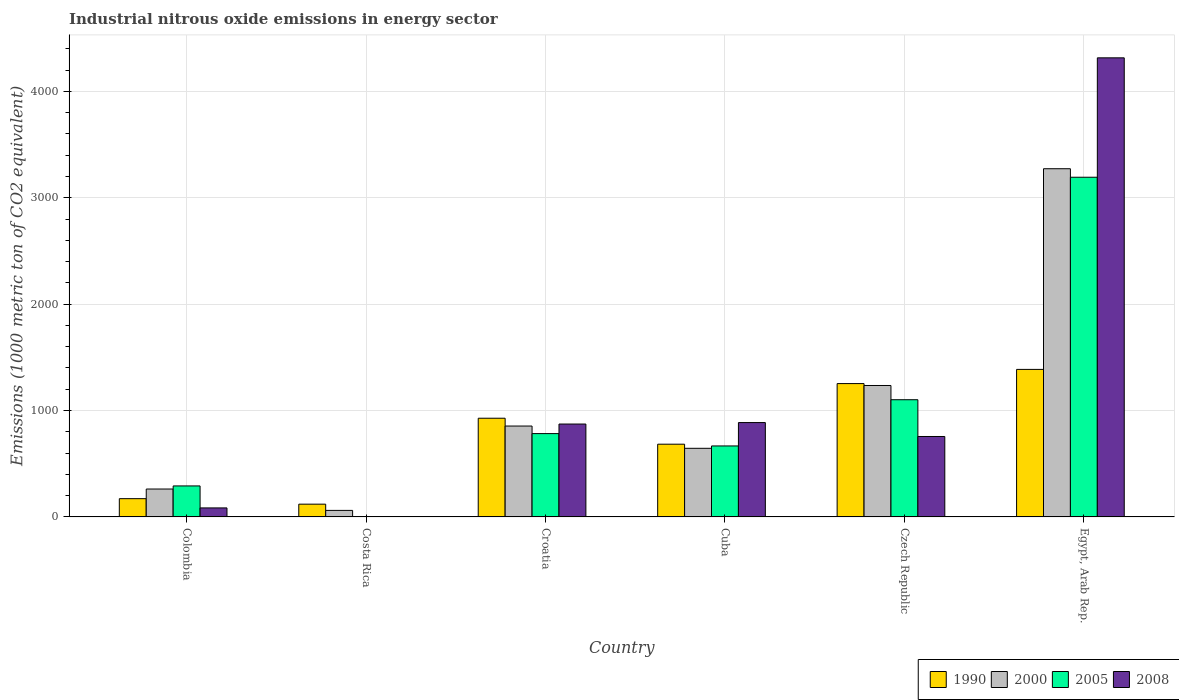How many different coloured bars are there?
Offer a very short reply. 4. What is the label of the 5th group of bars from the left?
Provide a succinct answer. Czech Republic. In how many cases, is the number of bars for a given country not equal to the number of legend labels?
Give a very brief answer. 0. What is the amount of industrial nitrous oxide emitted in 1990 in Czech Republic?
Keep it short and to the point. 1253.3. Across all countries, what is the maximum amount of industrial nitrous oxide emitted in 2008?
Your response must be concise. 4315. Across all countries, what is the minimum amount of industrial nitrous oxide emitted in 2005?
Your answer should be very brief. 3.1. In which country was the amount of industrial nitrous oxide emitted in 2008 maximum?
Ensure brevity in your answer.  Egypt, Arab Rep. What is the total amount of industrial nitrous oxide emitted in 2008 in the graph?
Make the answer very short. 6918.7. What is the difference between the amount of industrial nitrous oxide emitted in 2005 in Colombia and that in Czech Republic?
Ensure brevity in your answer.  -810.2. What is the difference between the amount of industrial nitrous oxide emitted in 2005 in Costa Rica and the amount of industrial nitrous oxide emitted in 1990 in Colombia?
Provide a succinct answer. -168.5. What is the average amount of industrial nitrous oxide emitted in 1990 per country?
Your answer should be very brief. 757.13. What is the difference between the amount of industrial nitrous oxide emitted of/in 2008 and amount of industrial nitrous oxide emitted of/in 2005 in Croatia?
Make the answer very short. 89.8. In how many countries, is the amount of industrial nitrous oxide emitted in 2000 greater than 1800 1000 metric ton?
Offer a very short reply. 1. What is the ratio of the amount of industrial nitrous oxide emitted in 1990 in Colombia to that in Czech Republic?
Offer a terse response. 0.14. What is the difference between the highest and the second highest amount of industrial nitrous oxide emitted in 2000?
Make the answer very short. 2037.3. What is the difference between the highest and the lowest amount of industrial nitrous oxide emitted in 2005?
Offer a very short reply. 3189.5. In how many countries, is the amount of industrial nitrous oxide emitted in 2008 greater than the average amount of industrial nitrous oxide emitted in 2008 taken over all countries?
Give a very brief answer. 1. Is the sum of the amount of industrial nitrous oxide emitted in 2000 in Colombia and Cuba greater than the maximum amount of industrial nitrous oxide emitted in 1990 across all countries?
Give a very brief answer. No. Are all the bars in the graph horizontal?
Ensure brevity in your answer.  No. How many countries are there in the graph?
Keep it short and to the point. 6. What is the difference between two consecutive major ticks on the Y-axis?
Provide a succinct answer. 1000. How many legend labels are there?
Give a very brief answer. 4. What is the title of the graph?
Give a very brief answer. Industrial nitrous oxide emissions in energy sector. Does "1969" appear as one of the legend labels in the graph?
Provide a short and direct response. No. What is the label or title of the Y-axis?
Offer a very short reply. Emissions (1000 metric ton of CO2 equivalent). What is the Emissions (1000 metric ton of CO2 equivalent) in 1990 in Colombia?
Your response must be concise. 171.6. What is the Emissions (1000 metric ton of CO2 equivalent) of 2000 in Colombia?
Your response must be concise. 262.3. What is the Emissions (1000 metric ton of CO2 equivalent) in 2005 in Colombia?
Make the answer very short. 291.3. What is the Emissions (1000 metric ton of CO2 equivalent) of 2008 in Colombia?
Offer a terse response. 84.7. What is the Emissions (1000 metric ton of CO2 equivalent) of 1990 in Costa Rica?
Your response must be concise. 120. What is the Emissions (1000 metric ton of CO2 equivalent) in 2000 in Costa Rica?
Keep it short and to the point. 61.4. What is the Emissions (1000 metric ton of CO2 equivalent) of 1990 in Croatia?
Your response must be concise. 927.7. What is the Emissions (1000 metric ton of CO2 equivalent) of 2000 in Croatia?
Your response must be concise. 854.3. What is the Emissions (1000 metric ton of CO2 equivalent) of 2005 in Croatia?
Give a very brief answer. 783.2. What is the Emissions (1000 metric ton of CO2 equivalent) of 2008 in Croatia?
Give a very brief answer. 873. What is the Emissions (1000 metric ton of CO2 equivalent) in 1990 in Cuba?
Provide a short and direct response. 683.6. What is the Emissions (1000 metric ton of CO2 equivalent) in 2000 in Cuba?
Your response must be concise. 645. What is the Emissions (1000 metric ton of CO2 equivalent) of 2005 in Cuba?
Provide a succinct answer. 667.1. What is the Emissions (1000 metric ton of CO2 equivalent) of 2008 in Cuba?
Your answer should be very brief. 886.9. What is the Emissions (1000 metric ton of CO2 equivalent) of 1990 in Czech Republic?
Provide a succinct answer. 1253.3. What is the Emissions (1000 metric ton of CO2 equivalent) of 2000 in Czech Republic?
Ensure brevity in your answer.  1235.4. What is the Emissions (1000 metric ton of CO2 equivalent) in 2005 in Czech Republic?
Offer a very short reply. 1101.5. What is the Emissions (1000 metric ton of CO2 equivalent) of 2008 in Czech Republic?
Offer a very short reply. 756. What is the Emissions (1000 metric ton of CO2 equivalent) in 1990 in Egypt, Arab Rep.?
Provide a succinct answer. 1386.6. What is the Emissions (1000 metric ton of CO2 equivalent) of 2000 in Egypt, Arab Rep.?
Keep it short and to the point. 3272.7. What is the Emissions (1000 metric ton of CO2 equivalent) of 2005 in Egypt, Arab Rep.?
Provide a succinct answer. 3192.6. What is the Emissions (1000 metric ton of CO2 equivalent) of 2008 in Egypt, Arab Rep.?
Offer a terse response. 4315. Across all countries, what is the maximum Emissions (1000 metric ton of CO2 equivalent) of 1990?
Provide a succinct answer. 1386.6. Across all countries, what is the maximum Emissions (1000 metric ton of CO2 equivalent) in 2000?
Offer a very short reply. 3272.7. Across all countries, what is the maximum Emissions (1000 metric ton of CO2 equivalent) of 2005?
Offer a terse response. 3192.6. Across all countries, what is the maximum Emissions (1000 metric ton of CO2 equivalent) in 2008?
Offer a very short reply. 4315. Across all countries, what is the minimum Emissions (1000 metric ton of CO2 equivalent) in 1990?
Your answer should be very brief. 120. Across all countries, what is the minimum Emissions (1000 metric ton of CO2 equivalent) of 2000?
Make the answer very short. 61.4. What is the total Emissions (1000 metric ton of CO2 equivalent) of 1990 in the graph?
Offer a terse response. 4542.8. What is the total Emissions (1000 metric ton of CO2 equivalent) in 2000 in the graph?
Your answer should be very brief. 6331.1. What is the total Emissions (1000 metric ton of CO2 equivalent) in 2005 in the graph?
Give a very brief answer. 6038.8. What is the total Emissions (1000 metric ton of CO2 equivalent) of 2008 in the graph?
Your response must be concise. 6918.7. What is the difference between the Emissions (1000 metric ton of CO2 equivalent) of 1990 in Colombia and that in Costa Rica?
Your answer should be very brief. 51.6. What is the difference between the Emissions (1000 metric ton of CO2 equivalent) of 2000 in Colombia and that in Costa Rica?
Offer a terse response. 200.9. What is the difference between the Emissions (1000 metric ton of CO2 equivalent) of 2005 in Colombia and that in Costa Rica?
Provide a short and direct response. 288.2. What is the difference between the Emissions (1000 metric ton of CO2 equivalent) of 2008 in Colombia and that in Costa Rica?
Your response must be concise. 81.6. What is the difference between the Emissions (1000 metric ton of CO2 equivalent) of 1990 in Colombia and that in Croatia?
Provide a succinct answer. -756.1. What is the difference between the Emissions (1000 metric ton of CO2 equivalent) of 2000 in Colombia and that in Croatia?
Offer a terse response. -592. What is the difference between the Emissions (1000 metric ton of CO2 equivalent) of 2005 in Colombia and that in Croatia?
Ensure brevity in your answer.  -491.9. What is the difference between the Emissions (1000 metric ton of CO2 equivalent) in 2008 in Colombia and that in Croatia?
Offer a very short reply. -788.3. What is the difference between the Emissions (1000 metric ton of CO2 equivalent) in 1990 in Colombia and that in Cuba?
Your answer should be very brief. -512. What is the difference between the Emissions (1000 metric ton of CO2 equivalent) of 2000 in Colombia and that in Cuba?
Ensure brevity in your answer.  -382.7. What is the difference between the Emissions (1000 metric ton of CO2 equivalent) in 2005 in Colombia and that in Cuba?
Keep it short and to the point. -375.8. What is the difference between the Emissions (1000 metric ton of CO2 equivalent) in 2008 in Colombia and that in Cuba?
Make the answer very short. -802.2. What is the difference between the Emissions (1000 metric ton of CO2 equivalent) in 1990 in Colombia and that in Czech Republic?
Ensure brevity in your answer.  -1081.7. What is the difference between the Emissions (1000 metric ton of CO2 equivalent) in 2000 in Colombia and that in Czech Republic?
Make the answer very short. -973.1. What is the difference between the Emissions (1000 metric ton of CO2 equivalent) of 2005 in Colombia and that in Czech Republic?
Ensure brevity in your answer.  -810.2. What is the difference between the Emissions (1000 metric ton of CO2 equivalent) in 2008 in Colombia and that in Czech Republic?
Provide a succinct answer. -671.3. What is the difference between the Emissions (1000 metric ton of CO2 equivalent) in 1990 in Colombia and that in Egypt, Arab Rep.?
Ensure brevity in your answer.  -1215. What is the difference between the Emissions (1000 metric ton of CO2 equivalent) of 2000 in Colombia and that in Egypt, Arab Rep.?
Offer a very short reply. -3010.4. What is the difference between the Emissions (1000 metric ton of CO2 equivalent) of 2005 in Colombia and that in Egypt, Arab Rep.?
Offer a terse response. -2901.3. What is the difference between the Emissions (1000 metric ton of CO2 equivalent) in 2008 in Colombia and that in Egypt, Arab Rep.?
Your answer should be compact. -4230.3. What is the difference between the Emissions (1000 metric ton of CO2 equivalent) in 1990 in Costa Rica and that in Croatia?
Your answer should be very brief. -807.7. What is the difference between the Emissions (1000 metric ton of CO2 equivalent) in 2000 in Costa Rica and that in Croatia?
Ensure brevity in your answer.  -792.9. What is the difference between the Emissions (1000 metric ton of CO2 equivalent) of 2005 in Costa Rica and that in Croatia?
Provide a succinct answer. -780.1. What is the difference between the Emissions (1000 metric ton of CO2 equivalent) in 2008 in Costa Rica and that in Croatia?
Your response must be concise. -869.9. What is the difference between the Emissions (1000 metric ton of CO2 equivalent) of 1990 in Costa Rica and that in Cuba?
Offer a terse response. -563.6. What is the difference between the Emissions (1000 metric ton of CO2 equivalent) of 2000 in Costa Rica and that in Cuba?
Keep it short and to the point. -583.6. What is the difference between the Emissions (1000 metric ton of CO2 equivalent) of 2005 in Costa Rica and that in Cuba?
Your answer should be compact. -664. What is the difference between the Emissions (1000 metric ton of CO2 equivalent) in 2008 in Costa Rica and that in Cuba?
Provide a short and direct response. -883.8. What is the difference between the Emissions (1000 metric ton of CO2 equivalent) of 1990 in Costa Rica and that in Czech Republic?
Your answer should be very brief. -1133.3. What is the difference between the Emissions (1000 metric ton of CO2 equivalent) of 2000 in Costa Rica and that in Czech Republic?
Offer a terse response. -1174. What is the difference between the Emissions (1000 metric ton of CO2 equivalent) of 2005 in Costa Rica and that in Czech Republic?
Your answer should be compact. -1098.4. What is the difference between the Emissions (1000 metric ton of CO2 equivalent) in 2008 in Costa Rica and that in Czech Republic?
Give a very brief answer. -752.9. What is the difference between the Emissions (1000 metric ton of CO2 equivalent) of 1990 in Costa Rica and that in Egypt, Arab Rep.?
Offer a terse response. -1266.6. What is the difference between the Emissions (1000 metric ton of CO2 equivalent) of 2000 in Costa Rica and that in Egypt, Arab Rep.?
Keep it short and to the point. -3211.3. What is the difference between the Emissions (1000 metric ton of CO2 equivalent) of 2005 in Costa Rica and that in Egypt, Arab Rep.?
Provide a short and direct response. -3189.5. What is the difference between the Emissions (1000 metric ton of CO2 equivalent) of 2008 in Costa Rica and that in Egypt, Arab Rep.?
Offer a very short reply. -4311.9. What is the difference between the Emissions (1000 metric ton of CO2 equivalent) of 1990 in Croatia and that in Cuba?
Give a very brief answer. 244.1. What is the difference between the Emissions (1000 metric ton of CO2 equivalent) in 2000 in Croatia and that in Cuba?
Your response must be concise. 209.3. What is the difference between the Emissions (1000 metric ton of CO2 equivalent) in 2005 in Croatia and that in Cuba?
Provide a succinct answer. 116.1. What is the difference between the Emissions (1000 metric ton of CO2 equivalent) of 1990 in Croatia and that in Czech Republic?
Your answer should be very brief. -325.6. What is the difference between the Emissions (1000 metric ton of CO2 equivalent) in 2000 in Croatia and that in Czech Republic?
Ensure brevity in your answer.  -381.1. What is the difference between the Emissions (1000 metric ton of CO2 equivalent) in 2005 in Croatia and that in Czech Republic?
Keep it short and to the point. -318.3. What is the difference between the Emissions (1000 metric ton of CO2 equivalent) in 2008 in Croatia and that in Czech Republic?
Provide a short and direct response. 117. What is the difference between the Emissions (1000 metric ton of CO2 equivalent) in 1990 in Croatia and that in Egypt, Arab Rep.?
Your response must be concise. -458.9. What is the difference between the Emissions (1000 metric ton of CO2 equivalent) of 2000 in Croatia and that in Egypt, Arab Rep.?
Offer a very short reply. -2418.4. What is the difference between the Emissions (1000 metric ton of CO2 equivalent) of 2005 in Croatia and that in Egypt, Arab Rep.?
Your response must be concise. -2409.4. What is the difference between the Emissions (1000 metric ton of CO2 equivalent) of 2008 in Croatia and that in Egypt, Arab Rep.?
Your answer should be compact. -3442. What is the difference between the Emissions (1000 metric ton of CO2 equivalent) of 1990 in Cuba and that in Czech Republic?
Your answer should be compact. -569.7. What is the difference between the Emissions (1000 metric ton of CO2 equivalent) in 2000 in Cuba and that in Czech Republic?
Offer a very short reply. -590.4. What is the difference between the Emissions (1000 metric ton of CO2 equivalent) in 2005 in Cuba and that in Czech Republic?
Your answer should be very brief. -434.4. What is the difference between the Emissions (1000 metric ton of CO2 equivalent) of 2008 in Cuba and that in Czech Republic?
Give a very brief answer. 130.9. What is the difference between the Emissions (1000 metric ton of CO2 equivalent) of 1990 in Cuba and that in Egypt, Arab Rep.?
Your response must be concise. -703. What is the difference between the Emissions (1000 metric ton of CO2 equivalent) of 2000 in Cuba and that in Egypt, Arab Rep.?
Keep it short and to the point. -2627.7. What is the difference between the Emissions (1000 metric ton of CO2 equivalent) in 2005 in Cuba and that in Egypt, Arab Rep.?
Keep it short and to the point. -2525.5. What is the difference between the Emissions (1000 metric ton of CO2 equivalent) of 2008 in Cuba and that in Egypt, Arab Rep.?
Provide a short and direct response. -3428.1. What is the difference between the Emissions (1000 metric ton of CO2 equivalent) in 1990 in Czech Republic and that in Egypt, Arab Rep.?
Offer a very short reply. -133.3. What is the difference between the Emissions (1000 metric ton of CO2 equivalent) in 2000 in Czech Republic and that in Egypt, Arab Rep.?
Provide a succinct answer. -2037.3. What is the difference between the Emissions (1000 metric ton of CO2 equivalent) of 2005 in Czech Republic and that in Egypt, Arab Rep.?
Make the answer very short. -2091.1. What is the difference between the Emissions (1000 metric ton of CO2 equivalent) of 2008 in Czech Republic and that in Egypt, Arab Rep.?
Your response must be concise. -3559. What is the difference between the Emissions (1000 metric ton of CO2 equivalent) in 1990 in Colombia and the Emissions (1000 metric ton of CO2 equivalent) in 2000 in Costa Rica?
Provide a succinct answer. 110.2. What is the difference between the Emissions (1000 metric ton of CO2 equivalent) in 1990 in Colombia and the Emissions (1000 metric ton of CO2 equivalent) in 2005 in Costa Rica?
Your response must be concise. 168.5. What is the difference between the Emissions (1000 metric ton of CO2 equivalent) of 1990 in Colombia and the Emissions (1000 metric ton of CO2 equivalent) of 2008 in Costa Rica?
Provide a short and direct response. 168.5. What is the difference between the Emissions (1000 metric ton of CO2 equivalent) of 2000 in Colombia and the Emissions (1000 metric ton of CO2 equivalent) of 2005 in Costa Rica?
Your response must be concise. 259.2. What is the difference between the Emissions (1000 metric ton of CO2 equivalent) of 2000 in Colombia and the Emissions (1000 metric ton of CO2 equivalent) of 2008 in Costa Rica?
Your answer should be very brief. 259.2. What is the difference between the Emissions (1000 metric ton of CO2 equivalent) of 2005 in Colombia and the Emissions (1000 metric ton of CO2 equivalent) of 2008 in Costa Rica?
Your response must be concise. 288.2. What is the difference between the Emissions (1000 metric ton of CO2 equivalent) in 1990 in Colombia and the Emissions (1000 metric ton of CO2 equivalent) in 2000 in Croatia?
Keep it short and to the point. -682.7. What is the difference between the Emissions (1000 metric ton of CO2 equivalent) of 1990 in Colombia and the Emissions (1000 metric ton of CO2 equivalent) of 2005 in Croatia?
Give a very brief answer. -611.6. What is the difference between the Emissions (1000 metric ton of CO2 equivalent) of 1990 in Colombia and the Emissions (1000 metric ton of CO2 equivalent) of 2008 in Croatia?
Provide a short and direct response. -701.4. What is the difference between the Emissions (1000 metric ton of CO2 equivalent) of 2000 in Colombia and the Emissions (1000 metric ton of CO2 equivalent) of 2005 in Croatia?
Ensure brevity in your answer.  -520.9. What is the difference between the Emissions (1000 metric ton of CO2 equivalent) in 2000 in Colombia and the Emissions (1000 metric ton of CO2 equivalent) in 2008 in Croatia?
Your answer should be compact. -610.7. What is the difference between the Emissions (1000 metric ton of CO2 equivalent) of 2005 in Colombia and the Emissions (1000 metric ton of CO2 equivalent) of 2008 in Croatia?
Offer a terse response. -581.7. What is the difference between the Emissions (1000 metric ton of CO2 equivalent) in 1990 in Colombia and the Emissions (1000 metric ton of CO2 equivalent) in 2000 in Cuba?
Your answer should be very brief. -473.4. What is the difference between the Emissions (1000 metric ton of CO2 equivalent) in 1990 in Colombia and the Emissions (1000 metric ton of CO2 equivalent) in 2005 in Cuba?
Offer a very short reply. -495.5. What is the difference between the Emissions (1000 metric ton of CO2 equivalent) of 1990 in Colombia and the Emissions (1000 metric ton of CO2 equivalent) of 2008 in Cuba?
Your response must be concise. -715.3. What is the difference between the Emissions (1000 metric ton of CO2 equivalent) of 2000 in Colombia and the Emissions (1000 metric ton of CO2 equivalent) of 2005 in Cuba?
Provide a succinct answer. -404.8. What is the difference between the Emissions (1000 metric ton of CO2 equivalent) in 2000 in Colombia and the Emissions (1000 metric ton of CO2 equivalent) in 2008 in Cuba?
Give a very brief answer. -624.6. What is the difference between the Emissions (1000 metric ton of CO2 equivalent) in 2005 in Colombia and the Emissions (1000 metric ton of CO2 equivalent) in 2008 in Cuba?
Your response must be concise. -595.6. What is the difference between the Emissions (1000 metric ton of CO2 equivalent) of 1990 in Colombia and the Emissions (1000 metric ton of CO2 equivalent) of 2000 in Czech Republic?
Provide a succinct answer. -1063.8. What is the difference between the Emissions (1000 metric ton of CO2 equivalent) of 1990 in Colombia and the Emissions (1000 metric ton of CO2 equivalent) of 2005 in Czech Republic?
Offer a very short reply. -929.9. What is the difference between the Emissions (1000 metric ton of CO2 equivalent) of 1990 in Colombia and the Emissions (1000 metric ton of CO2 equivalent) of 2008 in Czech Republic?
Keep it short and to the point. -584.4. What is the difference between the Emissions (1000 metric ton of CO2 equivalent) of 2000 in Colombia and the Emissions (1000 metric ton of CO2 equivalent) of 2005 in Czech Republic?
Make the answer very short. -839.2. What is the difference between the Emissions (1000 metric ton of CO2 equivalent) in 2000 in Colombia and the Emissions (1000 metric ton of CO2 equivalent) in 2008 in Czech Republic?
Give a very brief answer. -493.7. What is the difference between the Emissions (1000 metric ton of CO2 equivalent) of 2005 in Colombia and the Emissions (1000 metric ton of CO2 equivalent) of 2008 in Czech Republic?
Ensure brevity in your answer.  -464.7. What is the difference between the Emissions (1000 metric ton of CO2 equivalent) in 1990 in Colombia and the Emissions (1000 metric ton of CO2 equivalent) in 2000 in Egypt, Arab Rep.?
Give a very brief answer. -3101.1. What is the difference between the Emissions (1000 metric ton of CO2 equivalent) in 1990 in Colombia and the Emissions (1000 metric ton of CO2 equivalent) in 2005 in Egypt, Arab Rep.?
Your answer should be compact. -3021. What is the difference between the Emissions (1000 metric ton of CO2 equivalent) of 1990 in Colombia and the Emissions (1000 metric ton of CO2 equivalent) of 2008 in Egypt, Arab Rep.?
Offer a terse response. -4143.4. What is the difference between the Emissions (1000 metric ton of CO2 equivalent) in 2000 in Colombia and the Emissions (1000 metric ton of CO2 equivalent) in 2005 in Egypt, Arab Rep.?
Ensure brevity in your answer.  -2930.3. What is the difference between the Emissions (1000 metric ton of CO2 equivalent) of 2000 in Colombia and the Emissions (1000 metric ton of CO2 equivalent) of 2008 in Egypt, Arab Rep.?
Ensure brevity in your answer.  -4052.7. What is the difference between the Emissions (1000 metric ton of CO2 equivalent) in 2005 in Colombia and the Emissions (1000 metric ton of CO2 equivalent) in 2008 in Egypt, Arab Rep.?
Your response must be concise. -4023.7. What is the difference between the Emissions (1000 metric ton of CO2 equivalent) of 1990 in Costa Rica and the Emissions (1000 metric ton of CO2 equivalent) of 2000 in Croatia?
Make the answer very short. -734.3. What is the difference between the Emissions (1000 metric ton of CO2 equivalent) in 1990 in Costa Rica and the Emissions (1000 metric ton of CO2 equivalent) in 2005 in Croatia?
Your answer should be very brief. -663.2. What is the difference between the Emissions (1000 metric ton of CO2 equivalent) in 1990 in Costa Rica and the Emissions (1000 metric ton of CO2 equivalent) in 2008 in Croatia?
Make the answer very short. -753. What is the difference between the Emissions (1000 metric ton of CO2 equivalent) of 2000 in Costa Rica and the Emissions (1000 metric ton of CO2 equivalent) of 2005 in Croatia?
Your answer should be compact. -721.8. What is the difference between the Emissions (1000 metric ton of CO2 equivalent) in 2000 in Costa Rica and the Emissions (1000 metric ton of CO2 equivalent) in 2008 in Croatia?
Keep it short and to the point. -811.6. What is the difference between the Emissions (1000 metric ton of CO2 equivalent) in 2005 in Costa Rica and the Emissions (1000 metric ton of CO2 equivalent) in 2008 in Croatia?
Provide a short and direct response. -869.9. What is the difference between the Emissions (1000 metric ton of CO2 equivalent) in 1990 in Costa Rica and the Emissions (1000 metric ton of CO2 equivalent) in 2000 in Cuba?
Provide a succinct answer. -525. What is the difference between the Emissions (1000 metric ton of CO2 equivalent) in 1990 in Costa Rica and the Emissions (1000 metric ton of CO2 equivalent) in 2005 in Cuba?
Provide a short and direct response. -547.1. What is the difference between the Emissions (1000 metric ton of CO2 equivalent) of 1990 in Costa Rica and the Emissions (1000 metric ton of CO2 equivalent) of 2008 in Cuba?
Offer a very short reply. -766.9. What is the difference between the Emissions (1000 metric ton of CO2 equivalent) in 2000 in Costa Rica and the Emissions (1000 metric ton of CO2 equivalent) in 2005 in Cuba?
Give a very brief answer. -605.7. What is the difference between the Emissions (1000 metric ton of CO2 equivalent) of 2000 in Costa Rica and the Emissions (1000 metric ton of CO2 equivalent) of 2008 in Cuba?
Your response must be concise. -825.5. What is the difference between the Emissions (1000 metric ton of CO2 equivalent) in 2005 in Costa Rica and the Emissions (1000 metric ton of CO2 equivalent) in 2008 in Cuba?
Provide a short and direct response. -883.8. What is the difference between the Emissions (1000 metric ton of CO2 equivalent) in 1990 in Costa Rica and the Emissions (1000 metric ton of CO2 equivalent) in 2000 in Czech Republic?
Give a very brief answer. -1115.4. What is the difference between the Emissions (1000 metric ton of CO2 equivalent) of 1990 in Costa Rica and the Emissions (1000 metric ton of CO2 equivalent) of 2005 in Czech Republic?
Your answer should be very brief. -981.5. What is the difference between the Emissions (1000 metric ton of CO2 equivalent) in 1990 in Costa Rica and the Emissions (1000 metric ton of CO2 equivalent) in 2008 in Czech Republic?
Your answer should be compact. -636. What is the difference between the Emissions (1000 metric ton of CO2 equivalent) in 2000 in Costa Rica and the Emissions (1000 metric ton of CO2 equivalent) in 2005 in Czech Republic?
Your answer should be compact. -1040.1. What is the difference between the Emissions (1000 metric ton of CO2 equivalent) in 2000 in Costa Rica and the Emissions (1000 metric ton of CO2 equivalent) in 2008 in Czech Republic?
Offer a very short reply. -694.6. What is the difference between the Emissions (1000 metric ton of CO2 equivalent) in 2005 in Costa Rica and the Emissions (1000 metric ton of CO2 equivalent) in 2008 in Czech Republic?
Offer a very short reply. -752.9. What is the difference between the Emissions (1000 metric ton of CO2 equivalent) in 1990 in Costa Rica and the Emissions (1000 metric ton of CO2 equivalent) in 2000 in Egypt, Arab Rep.?
Offer a very short reply. -3152.7. What is the difference between the Emissions (1000 metric ton of CO2 equivalent) in 1990 in Costa Rica and the Emissions (1000 metric ton of CO2 equivalent) in 2005 in Egypt, Arab Rep.?
Your response must be concise. -3072.6. What is the difference between the Emissions (1000 metric ton of CO2 equivalent) of 1990 in Costa Rica and the Emissions (1000 metric ton of CO2 equivalent) of 2008 in Egypt, Arab Rep.?
Give a very brief answer. -4195. What is the difference between the Emissions (1000 metric ton of CO2 equivalent) of 2000 in Costa Rica and the Emissions (1000 metric ton of CO2 equivalent) of 2005 in Egypt, Arab Rep.?
Offer a terse response. -3131.2. What is the difference between the Emissions (1000 metric ton of CO2 equivalent) of 2000 in Costa Rica and the Emissions (1000 metric ton of CO2 equivalent) of 2008 in Egypt, Arab Rep.?
Give a very brief answer. -4253.6. What is the difference between the Emissions (1000 metric ton of CO2 equivalent) of 2005 in Costa Rica and the Emissions (1000 metric ton of CO2 equivalent) of 2008 in Egypt, Arab Rep.?
Keep it short and to the point. -4311.9. What is the difference between the Emissions (1000 metric ton of CO2 equivalent) in 1990 in Croatia and the Emissions (1000 metric ton of CO2 equivalent) in 2000 in Cuba?
Your answer should be very brief. 282.7. What is the difference between the Emissions (1000 metric ton of CO2 equivalent) in 1990 in Croatia and the Emissions (1000 metric ton of CO2 equivalent) in 2005 in Cuba?
Your answer should be very brief. 260.6. What is the difference between the Emissions (1000 metric ton of CO2 equivalent) in 1990 in Croatia and the Emissions (1000 metric ton of CO2 equivalent) in 2008 in Cuba?
Keep it short and to the point. 40.8. What is the difference between the Emissions (1000 metric ton of CO2 equivalent) in 2000 in Croatia and the Emissions (1000 metric ton of CO2 equivalent) in 2005 in Cuba?
Ensure brevity in your answer.  187.2. What is the difference between the Emissions (1000 metric ton of CO2 equivalent) of 2000 in Croatia and the Emissions (1000 metric ton of CO2 equivalent) of 2008 in Cuba?
Provide a short and direct response. -32.6. What is the difference between the Emissions (1000 metric ton of CO2 equivalent) in 2005 in Croatia and the Emissions (1000 metric ton of CO2 equivalent) in 2008 in Cuba?
Offer a terse response. -103.7. What is the difference between the Emissions (1000 metric ton of CO2 equivalent) in 1990 in Croatia and the Emissions (1000 metric ton of CO2 equivalent) in 2000 in Czech Republic?
Ensure brevity in your answer.  -307.7. What is the difference between the Emissions (1000 metric ton of CO2 equivalent) of 1990 in Croatia and the Emissions (1000 metric ton of CO2 equivalent) of 2005 in Czech Republic?
Make the answer very short. -173.8. What is the difference between the Emissions (1000 metric ton of CO2 equivalent) in 1990 in Croatia and the Emissions (1000 metric ton of CO2 equivalent) in 2008 in Czech Republic?
Keep it short and to the point. 171.7. What is the difference between the Emissions (1000 metric ton of CO2 equivalent) of 2000 in Croatia and the Emissions (1000 metric ton of CO2 equivalent) of 2005 in Czech Republic?
Your response must be concise. -247.2. What is the difference between the Emissions (1000 metric ton of CO2 equivalent) in 2000 in Croatia and the Emissions (1000 metric ton of CO2 equivalent) in 2008 in Czech Republic?
Offer a very short reply. 98.3. What is the difference between the Emissions (1000 metric ton of CO2 equivalent) in 2005 in Croatia and the Emissions (1000 metric ton of CO2 equivalent) in 2008 in Czech Republic?
Offer a terse response. 27.2. What is the difference between the Emissions (1000 metric ton of CO2 equivalent) of 1990 in Croatia and the Emissions (1000 metric ton of CO2 equivalent) of 2000 in Egypt, Arab Rep.?
Give a very brief answer. -2345. What is the difference between the Emissions (1000 metric ton of CO2 equivalent) of 1990 in Croatia and the Emissions (1000 metric ton of CO2 equivalent) of 2005 in Egypt, Arab Rep.?
Keep it short and to the point. -2264.9. What is the difference between the Emissions (1000 metric ton of CO2 equivalent) in 1990 in Croatia and the Emissions (1000 metric ton of CO2 equivalent) in 2008 in Egypt, Arab Rep.?
Your answer should be very brief. -3387.3. What is the difference between the Emissions (1000 metric ton of CO2 equivalent) in 2000 in Croatia and the Emissions (1000 metric ton of CO2 equivalent) in 2005 in Egypt, Arab Rep.?
Provide a short and direct response. -2338.3. What is the difference between the Emissions (1000 metric ton of CO2 equivalent) in 2000 in Croatia and the Emissions (1000 metric ton of CO2 equivalent) in 2008 in Egypt, Arab Rep.?
Give a very brief answer. -3460.7. What is the difference between the Emissions (1000 metric ton of CO2 equivalent) in 2005 in Croatia and the Emissions (1000 metric ton of CO2 equivalent) in 2008 in Egypt, Arab Rep.?
Ensure brevity in your answer.  -3531.8. What is the difference between the Emissions (1000 metric ton of CO2 equivalent) of 1990 in Cuba and the Emissions (1000 metric ton of CO2 equivalent) of 2000 in Czech Republic?
Offer a very short reply. -551.8. What is the difference between the Emissions (1000 metric ton of CO2 equivalent) in 1990 in Cuba and the Emissions (1000 metric ton of CO2 equivalent) in 2005 in Czech Republic?
Provide a succinct answer. -417.9. What is the difference between the Emissions (1000 metric ton of CO2 equivalent) of 1990 in Cuba and the Emissions (1000 metric ton of CO2 equivalent) of 2008 in Czech Republic?
Offer a terse response. -72.4. What is the difference between the Emissions (1000 metric ton of CO2 equivalent) of 2000 in Cuba and the Emissions (1000 metric ton of CO2 equivalent) of 2005 in Czech Republic?
Keep it short and to the point. -456.5. What is the difference between the Emissions (1000 metric ton of CO2 equivalent) of 2000 in Cuba and the Emissions (1000 metric ton of CO2 equivalent) of 2008 in Czech Republic?
Keep it short and to the point. -111. What is the difference between the Emissions (1000 metric ton of CO2 equivalent) of 2005 in Cuba and the Emissions (1000 metric ton of CO2 equivalent) of 2008 in Czech Republic?
Keep it short and to the point. -88.9. What is the difference between the Emissions (1000 metric ton of CO2 equivalent) of 1990 in Cuba and the Emissions (1000 metric ton of CO2 equivalent) of 2000 in Egypt, Arab Rep.?
Ensure brevity in your answer.  -2589.1. What is the difference between the Emissions (1000 metric ton of CO2 equivalent) of 1990 in Cuba and the Emissions (1000 metric ton of CO2 equivalent) of 2005 in Egypt, Arab Rep.?
Give a very brief answer. -2509. What is the difference between the Emissions (1000 metric ton of CO2 equivalent) of 1990 in Cuba and the Emissions (1000 metric ton of CO2 equivalent) of 2008 in Egypt, Arab Rep.?
Provide a succinct answer. -3631.4. What is the difference between the Emissions (1000 metric ton of CO2 equivalent) in 2000 in Cuba and the Emissions (1000 metric ton of CO2 equivalent) in 2005 in Egypt, Arab Rep.?
Keep it short and to the point. -2547.6. What is the difference between the Emissions (1000 metric ton of CO2 equivalent) of 2000 in Cuba and the Emissions (1000 metric ton of CO2 equivalent) of 2008 in Egypt, Arab Rep.?
Provide a short and direct response. -3670. What is the difference between the Emissions (1000 metric ton of CO2 equivalent) in 2005 in Cuba and the Emissions (1000 metric ton of CO2 equivalent) in 2008 in Egypt, Arab Rep.?
Make the answer very short. -3647.9. What is the difference between the Emissions (1000 metric ton of CO2 equivalent) in 1990 in Czech Republic and the Emissions (1000 metric ton of CO2 equivalent) in 2000 in Egypt, Arab Rep.?
Provide a succinct answer. -2019.4. What is the difference between the Emissions (1000 metric ton of CO2 equivalent) in 1990 in Czech Republic and the Emissions (1000 metric ton of CO2 equivalent) in 2005 in Egypt, Arab Rep.?
Give a very brief answer. -1939.3. What is the difference between the Emissions (1000 metric ton of CO2 equivalent) of 1990 in Czech Republic and the Emissions (1000 metric ton of CO2 equivalent) of 2008 in Egypt, Arab Rep.?
Your answer should be compact. -3061.7. What is the difference between the Emissions (1000 metric ton of CO2 equivalent) in 2000 in Czech Republic and the Emissions (1000 metric ton of CO2 equivalent) in 2005 in Egypt, Arab Rep.?
Provide a short and direct response. -1957.2. What is the difference between the Emissions (1000 metric ton of CO2 equivalent) in 2000 in Czech Republic and the Emissions (1000 metric ton of CO2 equivalent) in 2008 in Egypt, Arab Rep.?
Give a very brief answer. -3079.6. What is the difference between the Emissions (1000 metric ton of CO2 equivalent) of 2005 in Czech Republic and the Emissions (1000 metric ton of CO2 equivalent) of 2008 in Egypt, Arab Rep.?
Provide a succinct answer. -3213.5. What is the average Emissions (1000 metric ton of CO2 equivalent) in 1990 per country?
Keep it short and to the point. 757.13. What is the average Emissions (1000 metric ton of CO2 equivalent) of 2000 per country?
Provide a succinct answer. 1055.18. What is the average Emissions (1000 metric ton of CO2 equivalent) in 2005 per country?
Offer a very short reply. 1006.47. What is the average Emissions (1000 metric ton of CO2 equivalent) in 2008 per country?
Ensure brevity in your answer.  1153.12. What is the difference between the Emissions (1000 metric ton of CO2 equivalent) of 1990 and Emissions (1000 metric ton of CO2 equivalent) of 2000 in Colombia?
Your answer should be compact. -90.7. What is the difference between the Emissions (1000 metric ton of CO2 equivalent) in 1990 and Emissions (1000 metric ton of CO2 equivalent) in 2005 in Colombia?
Provide a short and direct response. -119.7. What is the difference between the Emissions (1000 metric ton of CO2 equivalent) in 1990 and Emissions (1000 metric ton of CO2 equivalent) in 2008 in Colombia?
Give a very brief answer. 86.9. What is the difference between the Emissions (1000 metric ton of CO2 equivalent) in 2000 and Emissions (1000 metric ton of CO2 equivalent) in 2008 in Colombia?
Your answer should be very brief. 177.6. What is the difference between the Emissions (1000 metric ton of CO2 equivalent) in 2005 and Emissions (1000 metric ton of CO2 equivalent) in 2008 in Colombia?
Give a very brief answer. 206.6. What is the difference between the Emissions (1000 metric ton of CO2 equivalent) in 1990 and Emissions (1000 metric ton of CO2 equivalent) in 2000 in Costa Rica?
Provide a succinct answer. 58.6. What is the difference between the Emissions (1000 metric ton of CO2 equivalent) of 1990 and Emissions (1000 metric ton of CO2 equivalent) of 2005 in Costa Rica?
Your answer should be compact. 116.9. What is the difference between the Emissions (1000 metric ton of CO2 equivalent) in 1990 and Emissions (1000 metric ton of CO2 equivalent) in 2008 in Costa Rica?
Your answer should be very brief. 116.9. What is the difference between the Emissions (1000 metric ton of CO2 equivalent) in 2000 and Emissions (1000 metric ton of CO2 equivalent) in 2005 in Costa Rica?
Provide a short and direct response. 58.3. What is the difference between the Emissions (1000 metric ton of CO2 equivalent) of 2000 and Emissions (1000 metric ton of CO2 equivalent) of 2008 in Costa Rica?
Make the answer very short. 58.3. What is the difference between the Emissions (1000 metric ton of CO2 equivalent) of 2005 and Emissions (1000 metric ton of CO2 equivalent) of 2008 in Costa Rica?
Your response must be concise. 0. What is the difference between the Emissions (1000 metric ton of CO2 equivalent) in 1990 and Emissions (1000 metric ton of CO2 equivalent) in 2000 in Croatia?
Ensure brevity in your answer.  73.4. What is the difference between the Emissions (1000 metric ton of CO2 equivalent) of 1990 and Emissions (1000 metric ton of CO2 equivalent) of 2005 in Croatia?
Keep it short and to the point. 144.5. What is the difference between the Emissions (1000 metric ton of CO2 equivalent) of 1990 and Emissions (1000 metric ton of CO2 equivalent) of 2008 in Croatia?
Make the answer very short. 54.7. What is the difference between the Emissions (1000 metric ton of CO2 equivalent) of 2000 and Emissions (1000 metric ton of CO2 equivalent) of 2005 in Croatia?
Your answer should be compact. 71.1. What is the difference between the Emissions (1000 metric ton of CO2 equivalent) of 2000 and Emissions (1000 metric ton of CO2 equivalent) of 2008 in Croatia?
Offer a terse response. -18.7. What is the difference between the Emissions (1000 metric ton of CO2 equivalent) in 2005 and Emissions (1000 metric ton of CO2 equivalent) in 2008 in Croatia?
Your answer should be very brief. -89.8. What is the difference between the Emissions (1000 metric ton of CO2 equivalent) in 1990 and Emissions (1000 metric ton of CO2 equivalent) in 2000 in Cuba?
Your answer should be compact. 38.6. What is the difference between the Emissions (1000 metric ton of CO2 equivalent) in 1990 and Emissions (1000 metric ton of CO2 equivalent) in 2008 in Cuba?
Your answer should be compact. -203.3. What is the difference between the Emissions (1000 metric ton of CO2 equivalent) in 2000 and Emissions (1000 metric ton of CO2 equivalent) in 2005 in Cuba?
Provide a short and direct response. -22.1. What is the difference between the Emissions (1000 metric ton of CO2 equivalent) in 2000 and Emissions (1000 metric ton of CO2 equivalent) in 2008 in Cuba?
Your answer should be compact. -241.9. What is the difference between the Emissions (1000 metric ton of CO2 equivalent) in 2005 and Emissions (1000 metric ton of CO2 equivalent) in 2008 in Cuba?
Make the answer very short. -219.8. What is the difference between the Emissions (1000 metric ton of CO2 equivalent) of 1990 and Emissions (1000 metric ton of CO2 equivalent) of 2005 in Czech Republic?
Provide a short and direct response. 151.8. What is the difference between the Emissions (1000 metric ton of CO2 equivalent) in 1990 and Emissions (1000 metric ton of CO2 equivalent) in 2008 in Czech Republic?
Your response must be concise. 497.3. What is the difference between the Emissions (1000 metric ton of CO2 equivalent) in 2000 and Emissions (1000 metric ton of CO2 equivalent) in 2005 in Czech Republic?
Provide a short and direct response. 133.9. What is the difference between the Emissions (1000 metric ton of CO2 equivalent) in 2000 and Emissions (1000 metric ton of CO2 equivalent) in 2008 in Czech Republic?
Ensure brevity in your answer.  479.4. What is the difference between the Emissions (1000 metric ton of CO2 equivalent) in 2005 and Emissions (1000 metric ton of CO2 equivalent) in 2008 in Czech Republic?
Provide a short and direct response. 345.5. What is the difference between the Emissions (1000 metric ton of CO2 equivalent) of 1990 and Emissions (1000 metric ton of CO2 equivalent) of 2000 in Egypt, Arab Rep.?
Make the answer very short. -1886.1. What is the difference between the Emissions (1000 metric ton of CO2 equivalent) in 1990 and Emissions (1000 metric ton of CO2 equivalent) in 2005 in Egypt, Arab Rep.?
Your response must be concise. -1806. What is the difference between the Emissions (1000 metric ton of CO2 equivalent) in 1990 and Emissions (1000 metric ton of CO2 equivalent) in 2008 in Egypt, Arab Rep.?
Offer a terse response. -2928.4. What is the difference between the Emissions (1000 metric ton of CO2 equivalent) of 2000 and Emissions (1000 metric ton of CO2 equivalent) of 2005 in Egypt, Arab Rep.?
Provide a succinct answer. 80.1. What is the difference between the Emissions (1000 metric ton of CO2 equivalent) of 2000 and Emissions (1000 metric ton of CO2 equivalent) of 2008 in Egypt, Arab Rep.?
Your answer should be compact. -1042.3. What is the difference between the Emissions (1000 metric ton of CO2 equivalent) in 2005 and Emissions (1000 metric ton of CO2 equivalent) in 2008 in Egypt, Arab Rep.?
Keep it short and to the point. -1122.4. What is the ratio of the Emissions (1000 metric ton of CO2 equivalent) of 1990 in Colombia to that in Costa Rica?
Give a very brief answer. 1.43. What is the ratio of the Emissions (1000 metric ton of CO2 equivalent) in 2000 in Colombia to that in Costa Rica?
Your response must be concise. 4.27. What is the ratio of the Emissions (1000 metric ton of CO2 equivalent) of 2005 in Colombia to that in Costa Rica?
Make the answer very short. 93.97. What is the ratio of the Emissions (1000 metric ton of CO2 equivalent) in 2008 in Colombia to that in Costa Rica?
Provide a succinct answer. 27.32. What is the ratio of the Emissions (1000 metric ton of CO2 equivalent) in 1990 in Colombia to that in Croatia?
Keep it short and to the point. 0.18. What is the ratio of the Emissions (1000 metric ton of CO2 equivalent) in 2000 in Colombia to that in Croatia?
Ensure brevity in your answer.  0.31. What is the ratio of the Emissions (1000 metric ton of CO2 equivalent) in 2005 in Colombia to that in Croatia?
Your answer should be very brief. 0.37. What is the ratio of the Emissions (1000 metric ton of CO2 equivalent) of 2008 in Colombia to that in Croatia?
Make the answer very short. 0.1. What is the ratio of the Emissions (1000 metric ton of CO2 equivalent) in 1990 in Colombia to that in Cuba?
Your response must be concise. 0.25. What is the ratio of the Emissions (1000 metric ton of CO2 equivalent) of 2000 in Colombia to that in Cuba?
Your response must be concise. 0.41. What is the ratio of the Emissions (1000 metric ton of CO2 equivalent) in 2005 in Colombia to that in Cuba?
Ensure brevity in your answer.  0.44. What is the ratio of the Emissions (1000 metric ton of CO2 equivalent) of 2008 in Colombia to that in Cuba?
Offer a terse response. 0.1. What is the ratio of the Emissions (1000 metric ton of CO2 equivalent) of 1990 in Colombia to that in Czech Republic?
Your answer should be compact. 0.14. What is the ratio of the Emissions (1000 metric ton of CO2 equivalent) of 2000 in Colombia to that in Czech Republic?
Your answer should be compact. 0.21. What is the ratio of the Emissions (1000 metric ton of CO2 equivalent) in 2005 in Colombia to that in Czech Republic?
Offer a terse response. 0.26. What is the ratio of the Emissions (1000 metric ton of CO2 equivalent) in 2008 in Colombia to that in Czech Republic?
Your response must be concise. 0.11. What is the ratio of the Emissions (1000 metric ton of CO2 equivalent) in 1990 in Colombia to that in Egypt, Arab Rep.?
Give a very brief answer. 0.12. What is the ratio of the Emissions (1000 metric ton of CO2 equivalent) of 2000 in Colombia to that in Egypt, Arab Rep.?
Your answer should be compact. 0.08. What is the ratio of the Emissions (1000 metric ton of CO2 equivalent) of 2005 in Colombia to that in Egypt, Arab Rep.?
Your answer should be very brief. 0.09. What is the ratio of the Emissions (1000 metric ton of CO2 equivalent) of 2008 in Colombia to that in Egypt, Arab Rep.?
Keep it short and to the point. 0.02. What is the ratio of the Emissions (1000 metric ton of CO2 equivalent) in 1990 in Costa Rica to that in Croatia?
Provide a short and direct response. 0.13. What is the ratio of the Emissions (1000 metric ton of CO2 equivalent) of 2000 in Costa Rica to that in Croatia?
Your response must be concise. 0.07. What is the ratio of the Emissions (1000 metric ton of CO2 equivalent) in 2005 in Costa Rica to that in Croatia?
Offer a terse response. 0. What is the ratio of the Emissions (1000 metric ton of CO2 equivalent) of 2008 in Costa Rica to that in Croatia?
Offer a very short reply. 0. What is the ratio of the Emissions (1000 metric ton of CO2 equivalent) of 1990 in Costa Rica to that in Cuba?
Make the answer very short. 0.18. What is the ratio of the Emissions (1000 metric ton of CO2 equivalent) of 2000 in Costa Rica to that in Cuba?
Your answer should be very brief. 0.1. What is the ratio of the Emissions (1000 metric ton of CO2 equivalent) in 2005 in Costa Rica to that in Cuba?
Give a very brief answer. 0. What is the ratio of the Emissions (1000 metric ton of CO2 equivalent) of 2008 in Costa Rica to that in Cuba?
Ensure brevity in your answer.  0. What is the ratio of the Emissions (1000 metric ton of CO2 equivalent) in 1990 in Costa Rica to that in Czech Republic?
Ensure brevity in your answer.  0.1. What is the ratio of the Emissions (1000 metric ton of CO2 equivalent) in 2000 in Costa Rica to that in Czech Republic?
Provide a succinct answer. 0.05. What is the ratio of the Emissions (1000 metric ton of CO2 equivalent) of 2005 in Costa Rica to that in Czech Republic?
Your answer should be compact. 0. What is the ratio of the Emissions (1000 metric ton of CO2 equivalent) of 2008 in Costa Rica to that in Czech Republic?
Offer a very short reply. 0. What is the ratio of the Emissions (1000 metric ton of CO2 equivalent) in 1990 in Costa Rica to that in Egypt, Arab Rep.?
Ensure brevity in your answer.  0.09. What is the ratio of the Emissions (1000 metric ton of CO2 equivalent) of 2000 in Costa Rica to that in Egypt, Arab Rep.?
Give a very brief answer. 0.02. What is the ratio of the Emissions (1000 metric ton of CO2 equivalent) in 2005 in Costa Rica to that in Egypt, Arab Rep.?
Your response must be concise. 0. What is the ratio of the Emissions (1000 metric ton of CO2 equivalent) in 2008 in Costa Rica to that in Egypt, Arab Rep.?
Offer a terse response. 0. What is the ratio of the Emissions (1000 metric ton of CO2 equivalent) in 1990 in Croatia to that in Cuba?
Your answer should be compact. 1.36. What is the ratio of the Emissions (1000 metric ton of CO2 equivalent) in 2000 in Croatia to that in Cuba?
Give a very brief answer. 1.32. What is the ratio of the Emissions (1000 metric ton of CO2 equivalent) in 2005 in Croatia to that in Cuba?
Ensure brevity in your answer.  1.17. What is the ratio of the Emissions (1000 metric ton of CO2 equivalent) in 2008 in Croatia to that in Cuba?
Keep it short and to the point. 0.98. What is the ratio of the Emissions (1000 metric ton of CO2 equivalent) in 1990 in Croatia to that in Czech Republic?
Keep it short and to the point. 0.74. What is the ratio of the Emissions (1000 metric ton of CO2 equivalent) in 2000 in Croatia to that in Czech Republic?
Provide a short and direct response. 0.69. What is the ratio of the Emissions (1000 metric ton of CO2 equivalent) of 2005 in Croatia to that in Czech Republic?
Provide a succinct answer. 0.71. What is the ratio of the Emissions (1000 metric ton of CO2 equivalent) of 2008 in Croatia to that in Czech Republic?
Make the answer very short. 1.15. What is the ratio of the Emissions (1000 metric ton of CO2 equivalent) in 1990 in Croatia to that in Egypt, Arab Rep.?
Ensure brevity in your answer.  0.67. What is the ratio of the Emissions (1000 metric ton of CO2 equivalent) of 2000 in Croatia to that in Egypt, Arab Rep.?
Give a very brief answer. 0.26. What is the ratio of the Emissions (1000 metric ton of CO2 equivalent) of 2005 in Croatia to that in Egypt, Arab Rep.?
Your answer should be very brief. 0.25. What is the ratio of the Emissions (1000 metric ton of CO2 equivalent) in 2008 in Croatia to that in Egypt, Arab Rep.?
Offer a terse response. 0.2. What is the ratio of the Emissions (1000 metric ton of CO2 equivalent) in 1990 in Cuba to that in Czech Republic?
Offer a very short reply. 0.55. What is the ratio of the Emissions (1000 metric ton of CO2 equivalent) in 2000 in Cuba to that in Czech Republic?
Provide a short and direct response. 0.52. What is the ratio of the Emissions (1000 metric ton of CO2 equivalent) in 2005 in Cuba to that in Czech Republic?
Make the answer very short. 0.61. What is the ratio of the Emissions (1000 metric ton of CO2 equivalent) in 2008 in Cuba to that in Czech Republic?
Your answer should be very brief. 1.17. What is the ratio of the Emissions (1000 metric ton of CO2 equivalent) in 1990 in Cuba to that in Egypt, Arab Rep.?
Your answer should be very brief. 0.49. What is the ratio of the Emissions (1000 metric ton of CO2 equivalent) of 2000 in Cuba to that in Egypt, Arab Rep.?
Provide a short and direct response. 0.2. What is the ratio of the Emissions (1000 metric ton of CO2 equivalent) in 2005 in Cuba to that in Egypt, Arab Rep.?
Offer a very short reply. 0.21. What is the ratio of the Emissions (1000 metric ton of CO2 equivalent) of 2008 in Cuba to that in Egypt, Arab Rep.?
Keep it short and to the point. 0.21. What is the ratio of the Emissions (1000 metric ton of CO2 equivalent) of 1990 in Czech Republic to that in Egypt, Arab Rep.?
Provide a short and direct response. 0.9. What is the ratio of the Emissions (1000 metric ton of CO2 equivalent) in 2000 in Czech Republic to that in Egypt, Arab Rep.?
Make the answer very short. 0.38. What is the ratio of the Emissions (1000 metric ton of CO2 equivalent) in 2005 in Czech Republic to that in Egypt, Arab Rep.?
Give a very brief answer. 0.34. What is the ratio of the Emissions (1000 metric ton of CO2 equivalent) in 2008 in Czech Republic to that in Egypt, Arab Rep.?
Your answer should be very brief. 0.18. What is the difference between the highest and the second highest Emissions (1000 metric ton of CO2 equivalent) in 1990?
Ensure brevity in your answer.  133.3. What is the difference between the highest and the second highest Emissions (1000 metric ton of CO2 equivalent) in 2000?
Offer a very short reply. 2037.3. What is the difference between the highest and the second highest Emissions (1000 metric ton of CO2 equivalent) of 2005?
Provide a short and direct response. 2091.1. What is the difference between the highest and the second highest Emissions (1000 metric ton of CO2 equivalent) in 2008?
Your answer should be compact. 3428.1. What is the difference between the highest and the lowest Emissions (1000 metric ton of CO2 equivalent) of 1990?
Provide a succinct answer. 1266.6. What is the difference between the highest and the lowest Emissions (1000 metric ton of CO2 equivalent) of 2000?
Your answer should be compact. 3211.3. What is the difference between the highest and the lowest Emissions (1000 metric ton of CO2 equivalent) in 2005?
Provide a succinct answer. 3189.5. What is the difference between the highest and the lowest Emissions (1000 metric ton of CO2 equivalent) of 2008?
Provide a short and direct response. 4311.9. 